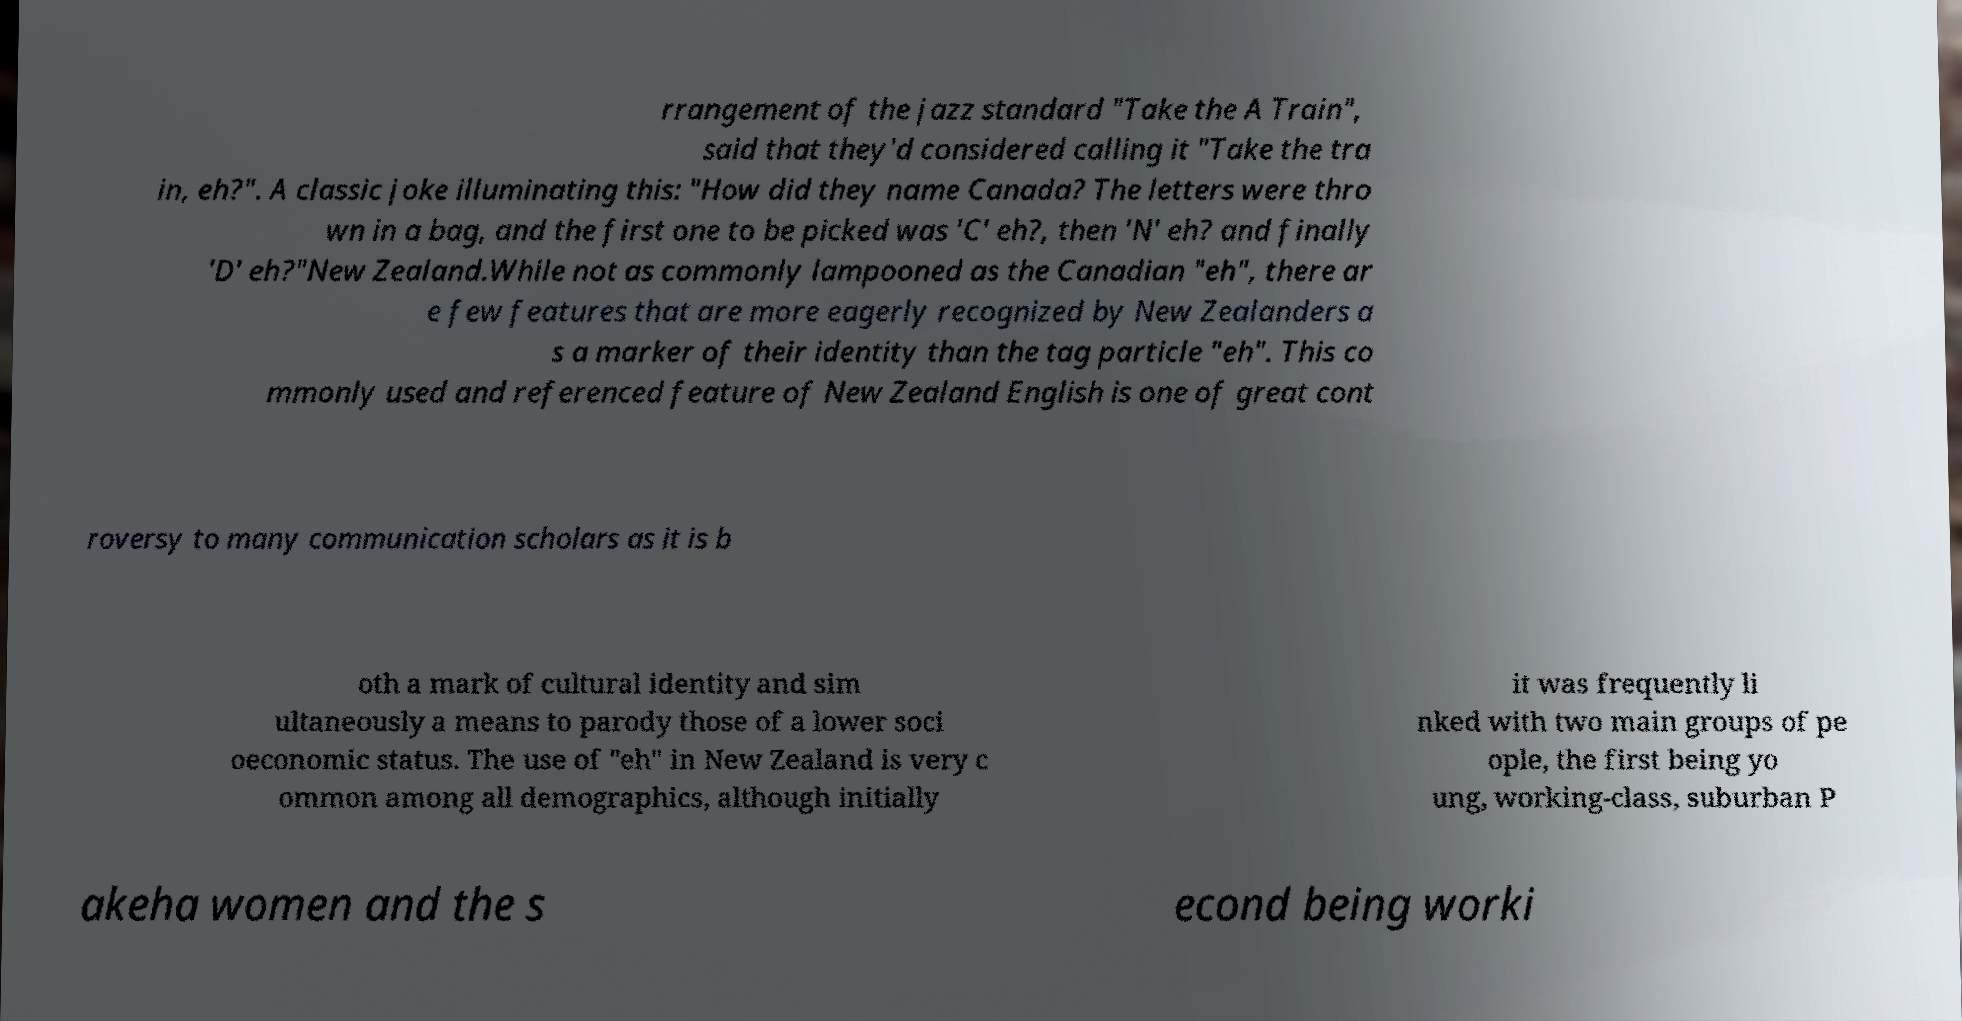Can you accurately transcribe the text from the provided image for me? rrangement of the jazz standard "Take the A Train", said that they'd considered calling it "Take the tra in, eh?". A classic joke illuminating this: "How did they name Canada? The letters were thro wn in a bag, and the first one to be picked was 'C' eh?, then 'N' eh? and finally 'D' eh?"New Zealand.While not as commonly lampooned as the Canadian "eh", there ar e few features that are more eagerly recognized by New Zealanders a s a marker of their identity than the tag particle "eh". This co mmonly used and referenced feature of New Zealand English is one of great cont roversy to many communication scholars as it is b oth a mark of cultural identity and sim ultaneously a means to parody those of a lower soci oeconomic status. The use of "eh" in New Zealand is very c ommon among all demographics, although initially it was frequently li nked with two main groups of pe ople, the first being yo ung, working-class, suburban P akeha women and the s econd being worki 